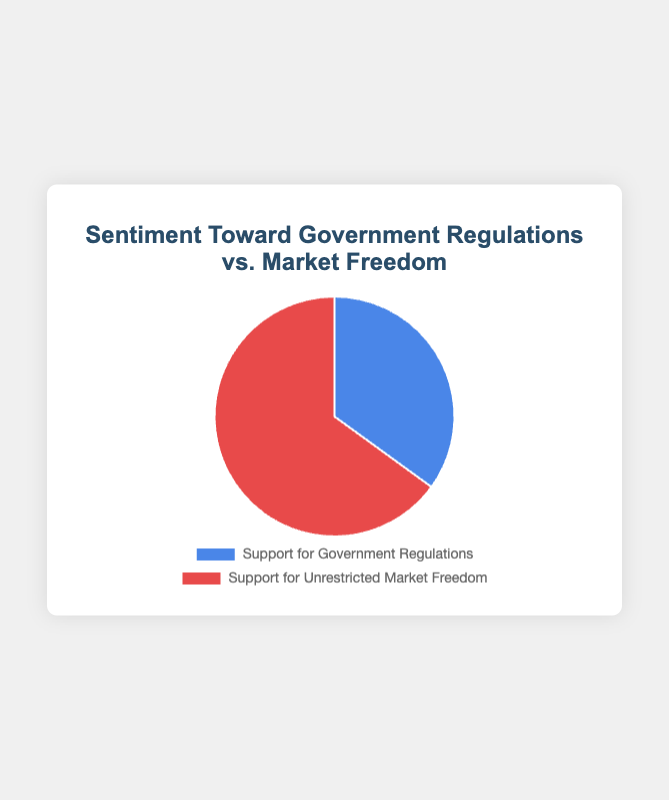What are the two categories represented in the pie chart? The pie chart represents two categories: "Support for Government Regulations" and "Support for Unrestricted Market Freedom."
Answer: "Support for Government Regulations" and "Support for Unrestricted Market Freedom." Which category has the higher percentage of support? By observing the pie chart, "Support for Unrestricted Market Freedom" takes up a larger portion, marked with red, compared to "Support for Government Regulations."
Answer: "Support for Unrestricted Market Freedom" How much more support is there for "Support for Unrestricted Market Freedom" compared to "Support for Government Regulations"? The difference in percentage between "Support for Unrestricted Market Freedom" (65%) and "Support for Government Regulations" (35%) is calculated as 65% - 35%.
Answer: 30% What is the combined percentage of people who support either government regulations or market freedom? Adding the two percentages together gives the total 35% for government regulations plus 65% for market freedom, resulting in 35% + 65%.
Answer: 100% What color represents "Support for Government Regulations"? The pie chart uses blue to denote "Support for Government Regulations."
Answer: Blue What is the ratio of support between "Unrestricted Market Freedom" and "Government Regulations"? The ratio is calculated by dividing the percentage of "Unrestricted Market Freedom" (65%) by the percentage of "Government Regulations" (35%), which is 65/35. Simplifying the fraction yields approximately 1.86:1.
Answer: 1.86:1 Is the majority of sentiment in favor of government regulations or market freedom? The majority is determined by the larger percentage. Since "Support for Unrestricted Market Freedom" has 65%, it is the majority compared to "Support for Government Regulations" at 35%.
Answer: Market freedom If the sentiment toward "Support for Government Regulations" increased by 10%, what would the new percentage be for both categories? If "Support for Government Regulations" increased by 10%, it would become 45%. The total must still be 100%, so "Support for Unrestricted Market Freedom" would decrease by 10%, becoming 55%.
Answer: 45% for Government Regulations, 55% for Market Freedom What is the proportion of "Support for Unrestricted Market Freedom" to the total support expressed in the chart? The proportion is the percentage of "Support for Unrestricted Market Freedom" (65%) out of the total 100%. The proportion is therefore 65/100.
Answer: 0.65 